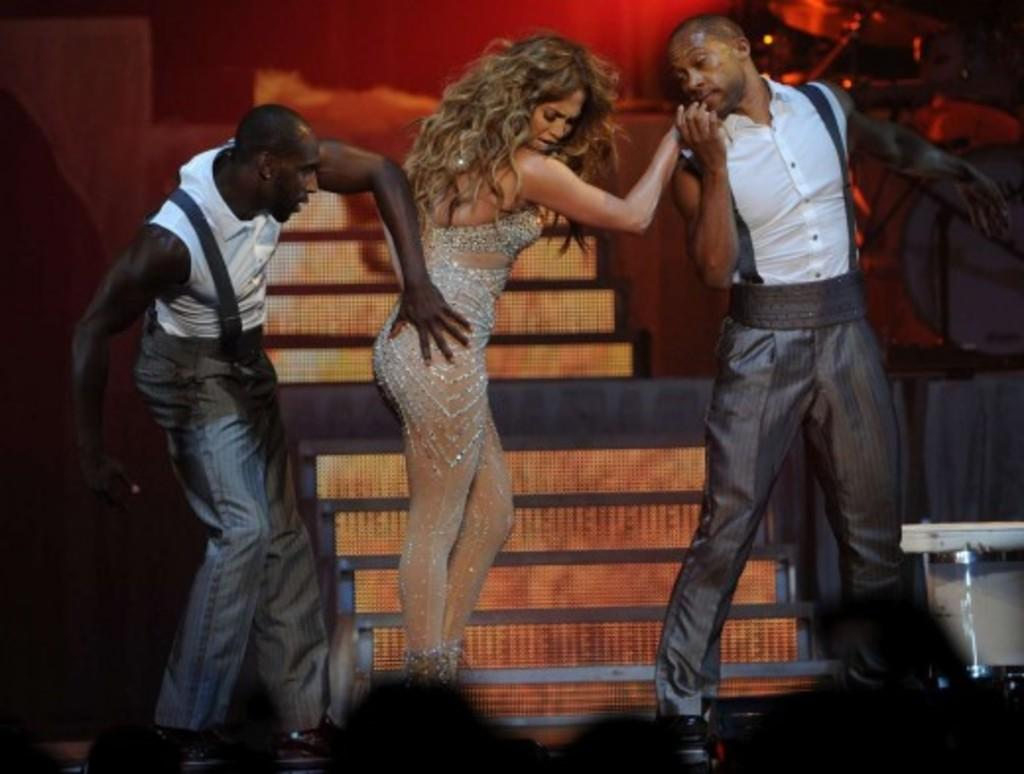How many people are present in the image? There are three people standing in the image. What can be seen in the background of the image? There are stairs and a musical instrument visible in the background of the image. What type of milk is being used to play the musical instrument in the image? There is no milk present in the image, and the musical instrument is not being played. 